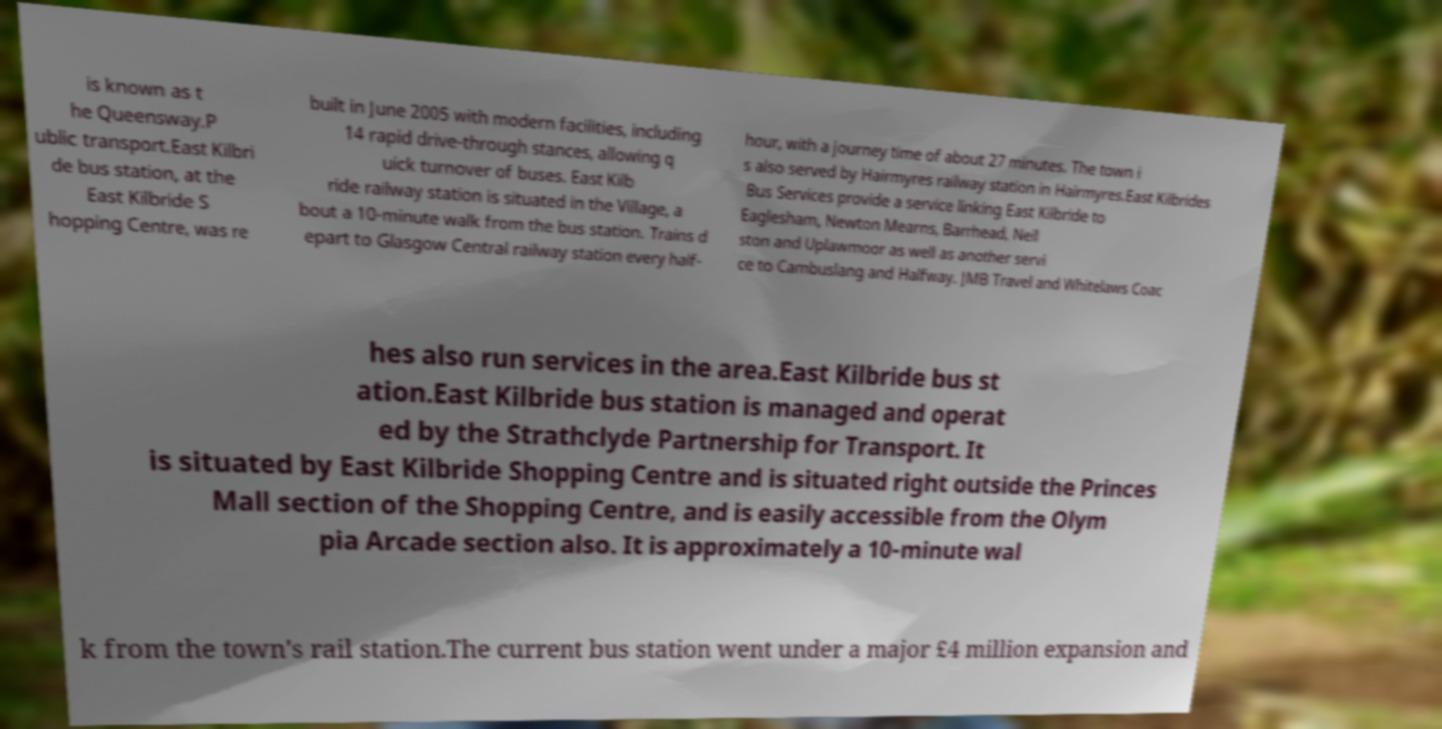Could you extract and type out the text from this image? is known as t he Queensway.P ublic transport.East Kilbri de bus station, at the East Kilbride S hopping Centre, was re built in June 2005 with modern facilities, including 14 rapid drive-through stances, allowing q uick turnover of buses. East Kilb ride railway station is situated in the Village, a bout a 10-minute walk from the bus station. Trains d epart to Glasgow Central railway station every half- hour, with a journey time of about 27 minutes. The town i s also served by Hairmyres railway station in Hairmyres.East Kilbrides Bus Services provide a service linking East Kilbride to Eaglesham, Newton Mearns, Barrhead, Neil ston and Uplawmoor as well as another servi ce to Cambuslang and Halfway. JMB Travel and Whitelaws Coac hes also run services in the area.East Kilbride bus st ation.East Kilbride bus station is managed and operat ed by the Strathclyde Partnership for Transport. It is situated by East Kilbride Shopping Centre and is situated right outside the Princes Mall section of the Shopping Centre, and is easily accessible from the Olym pia Arcade section also. It is approximately a 10-minute wal k from the town's rail station.The current bus station went under a major £4 million expansion and 